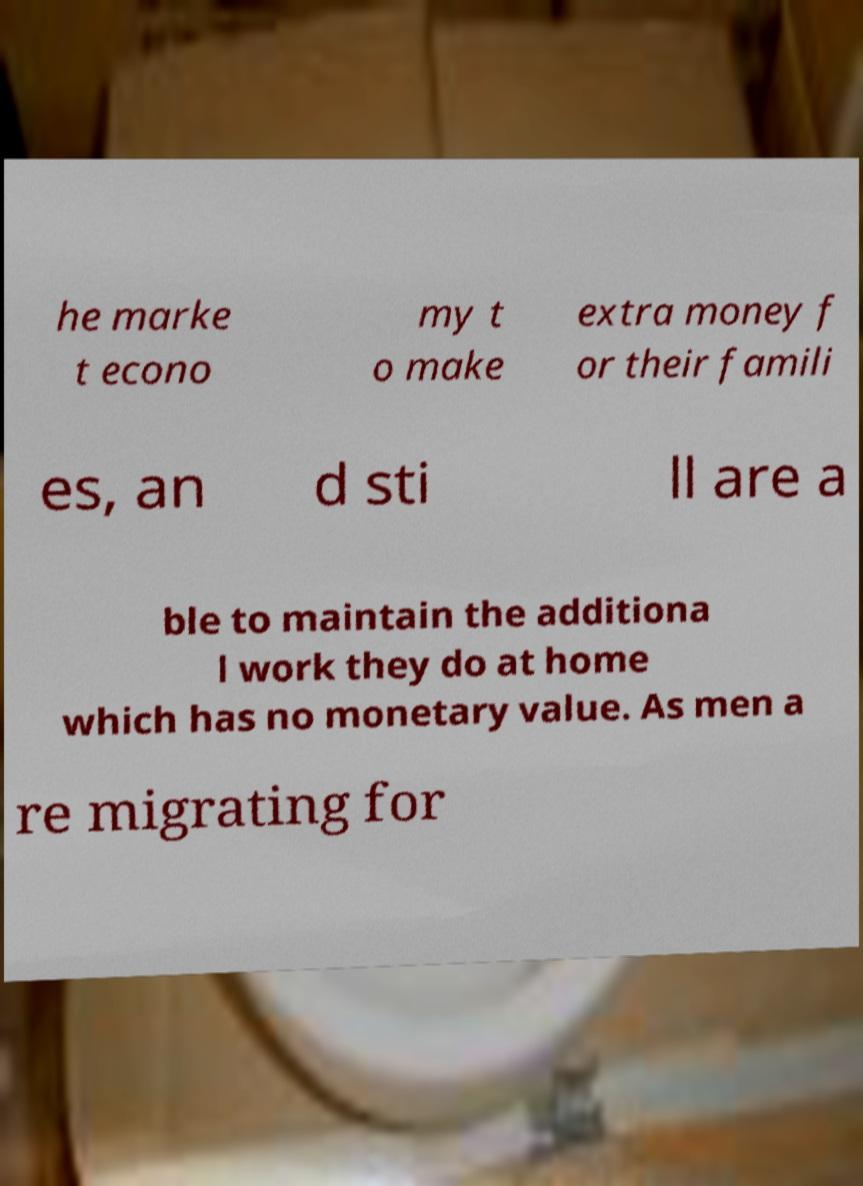I need the written content from this picture converted into text. Can you do that? he marke t econo my t o make extra money f or their famili es, an d sti ll are a ble to maintain the additiona l work they do at home which has no monetary value. As men a re migrating for 